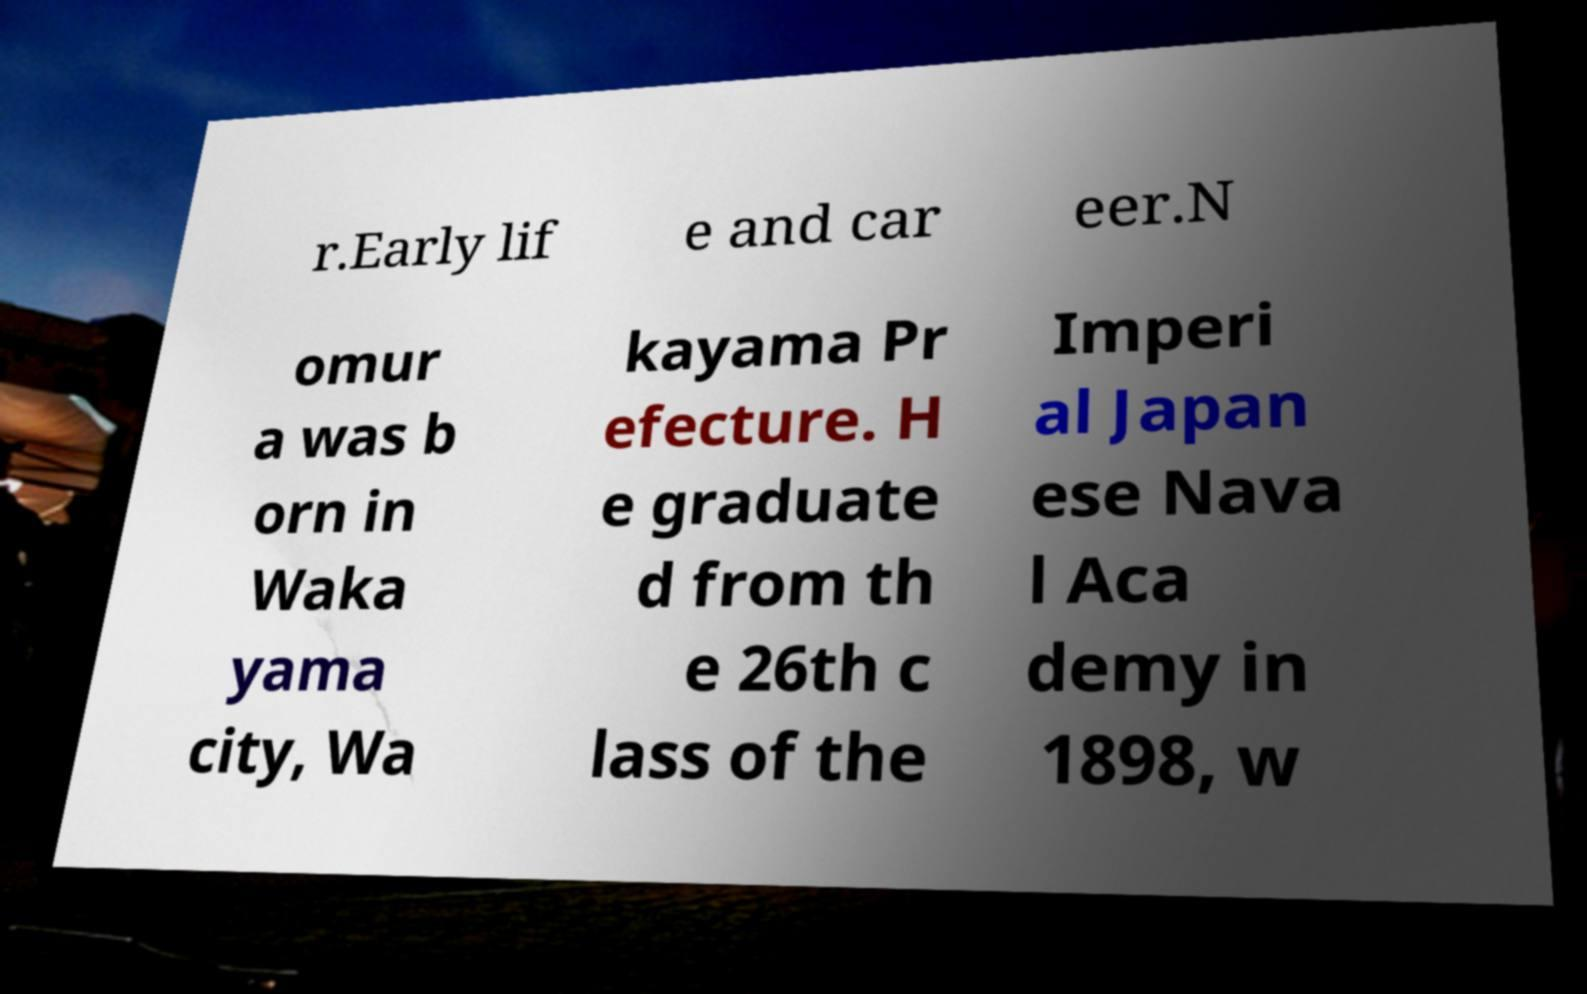Could you assist in decoding the text presented in this image and type it out clearly? r.Early lif e and car eer.N omur a was b orn in Waka yama city, Wa kayama Pr efecture. H e graduate d from th e 26th c lass of the Imperi al Japan ese Nava l Aca demy in 1898, w 